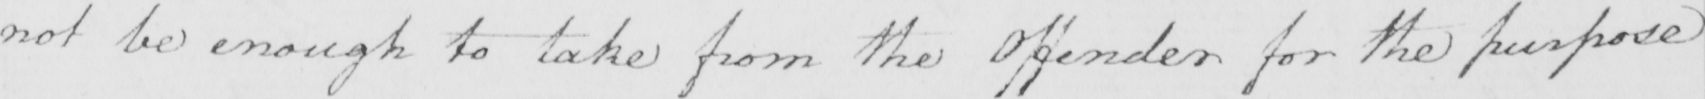Transcribe the text shown in this historical manuscript line. not be enough to take from the Offender for the purpose 